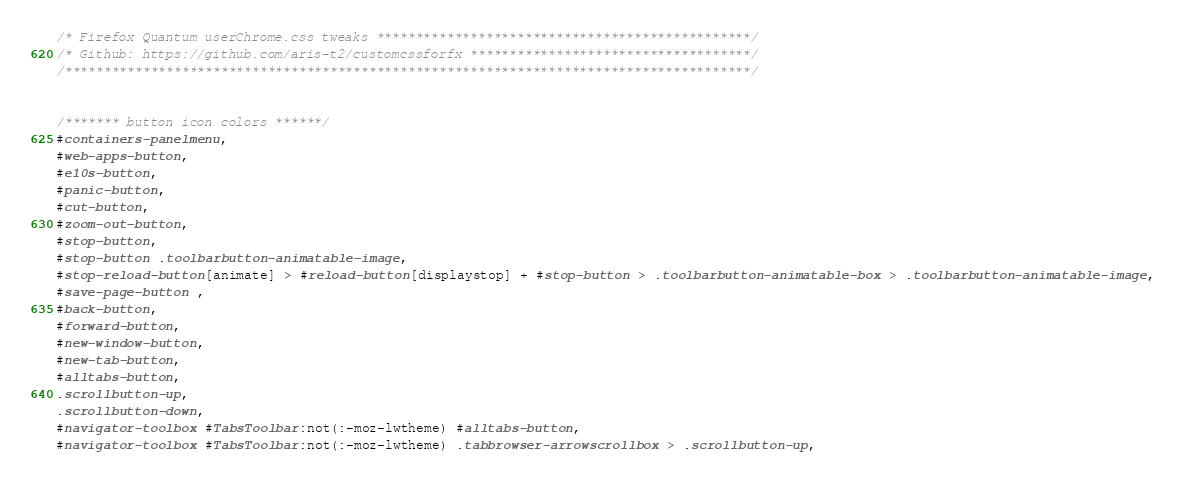<code> <loc_0><loc_0><loc_500><loc_500><_CSS_>/* Firefox Quantum userChrome.css tweaks ************************************************/
/* Github: https://github.com/aris-t2/customcssforfx ************************************/
/****************************************************************************************/


/******* button icon colors ******/
#containers-panelmenu,
#web-apps-button,
#e10s-button,
#panic-button,
#cut-button,
#zoom-out-button,
#stop-button,
#stop-button .toolbarbutton-animatable-image,
#stop-reload-button[animate] > #reload-button[displaystop] + #stop-button > .toolbarbutton-animatable-box > .toolbarbutton-animatable-image,
#save-page-button ,
#back-button,
#forward-button,
#new-window-button,
#new-tab-button,
#alltabs-button,
.scrollbutton-up,
.scrollbutton-down,
#navigator-toolbox #TabsToolbar:not(:-moz-lwtheme) #alltabs-button,
#navigator-toolbox #TabsToolbar:not(:-moz-lwtheme) .tabbrowser-arrowscrollbox > .scrollbutton-up,</code> 